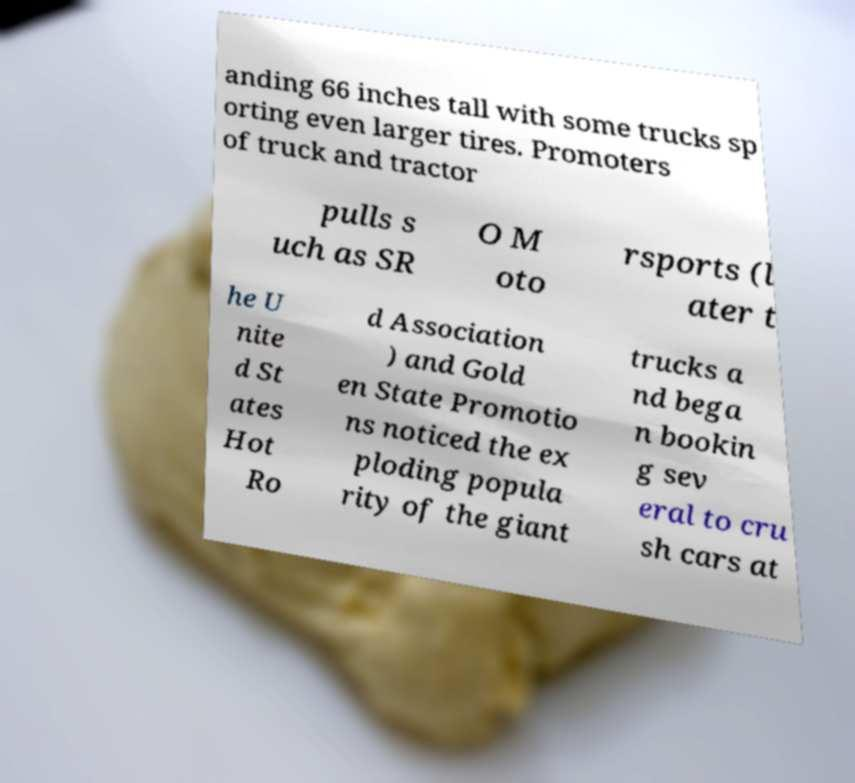What messages or text are displayed in this image? I need them in a readable, typed format. anding 66 inches tall with some trucks sp orting even larger tires. Promoters of truck and tractor pulls s uch as SR O M oto rsports (l ater t he U nite d St ates Hot Ro d Association ) and Gold en State Promotio ns noticed the ex ploding popula rity of the giant trucks a nd bega n bookin g sev eral to cru sh cars at 